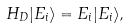Convert formula to latex. <formula><loc_0><loc_0><loc_500><loc_500>H _ { D } | E _ { i } \rangle = E _ { i } | E _ { i } \rangle ,</formula> 